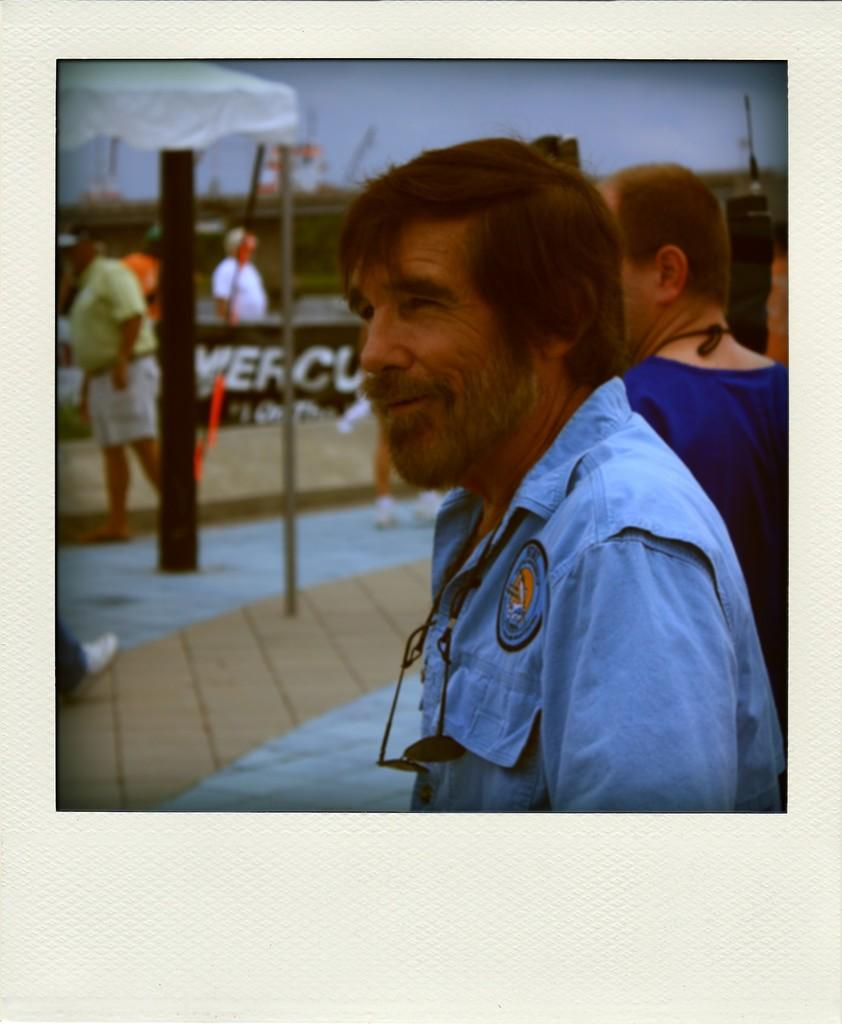What is located on the left side of the image? There is a person standing on the left side of the image, and there is also a board on the left side. Can you describe the person on the right side of the image? The person on the right side of the image is wearing a blue dress and is also wearing spectacles. How many women are visible in the image? There is no information about the gender of the people in the image, so it cannot be determined if there are any women present. 